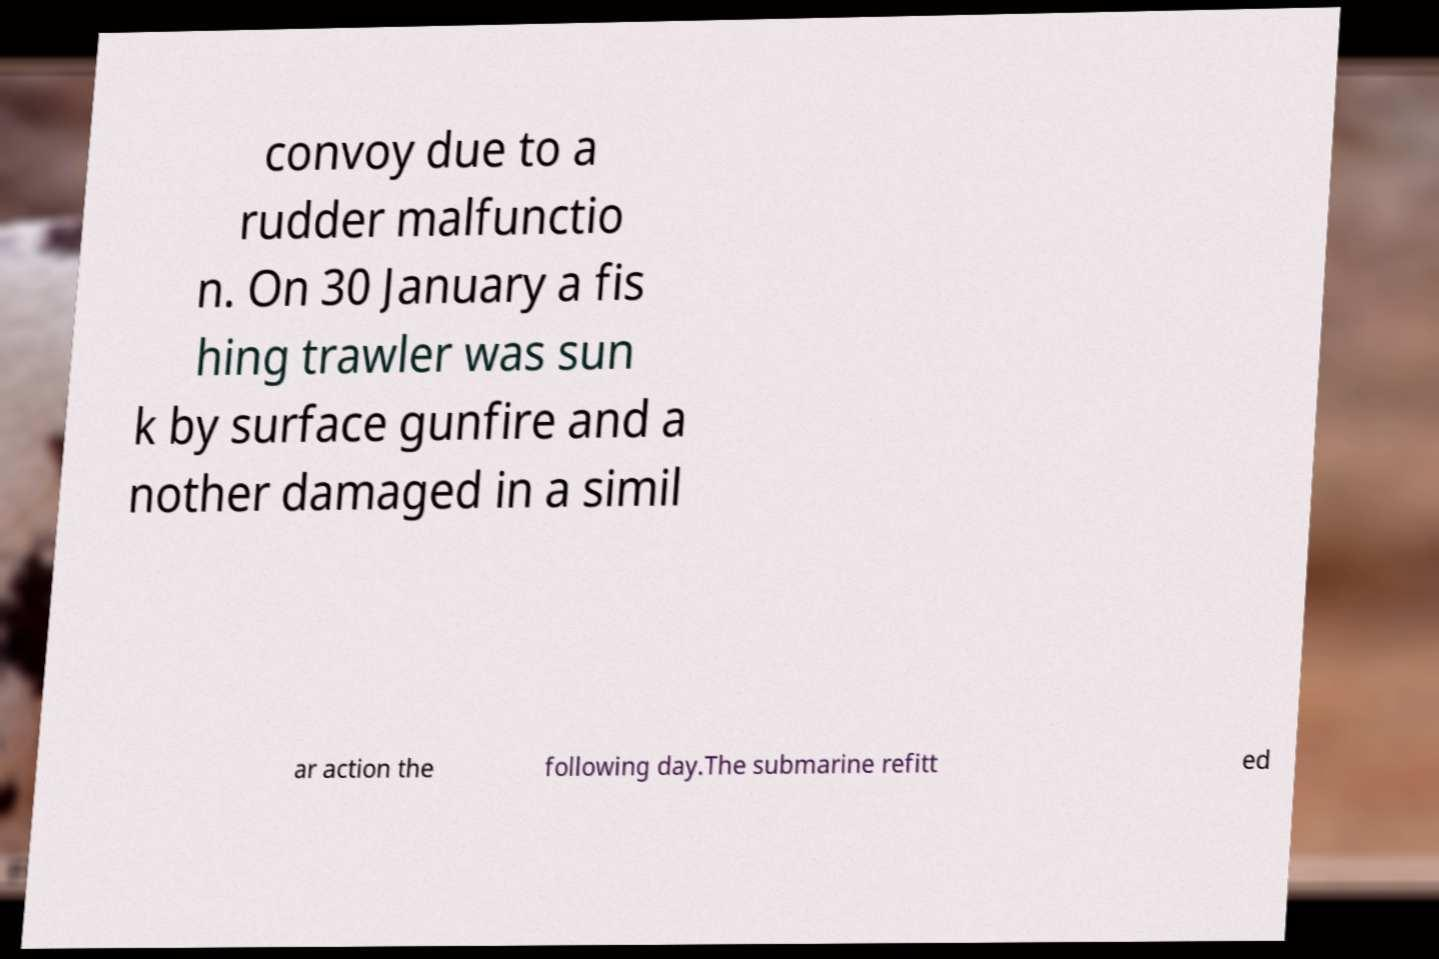I need the written content from this picture converted into text. Can you do that? convoy due to a rudder malfunctio n. On 30 January a fis hing trawler was sun k by surface gunfire and a nother damaged in a simil ar action the following day.The submarine refitt ed 